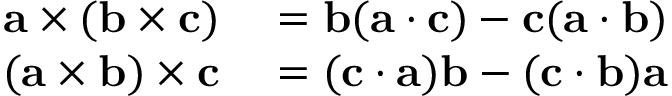Convert formula to latex. <formula><loc_0><loc_0><loc_500><loc_500>\begin{array} { r l } { a \times ( b \times c ) } & = b ( a \cdot c ) - c ( a \cdot b ) } \\ { ( a \times b ) \times c } & = ( c \cdot a ) b - ( c \cdot b ) a } \end{array}</formula> 